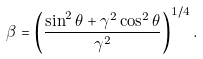<formula> <loc_0><loc_0><loc_500><loc_500>\beta = \left ( { \frac { \sin ^ { 2 } \theta + \gamma ^ { 2 } \cos ^ { 2 } \theta } { \gamma ^ { 2 } } } \right ) ^ { 1 / 4 } .</formula> 